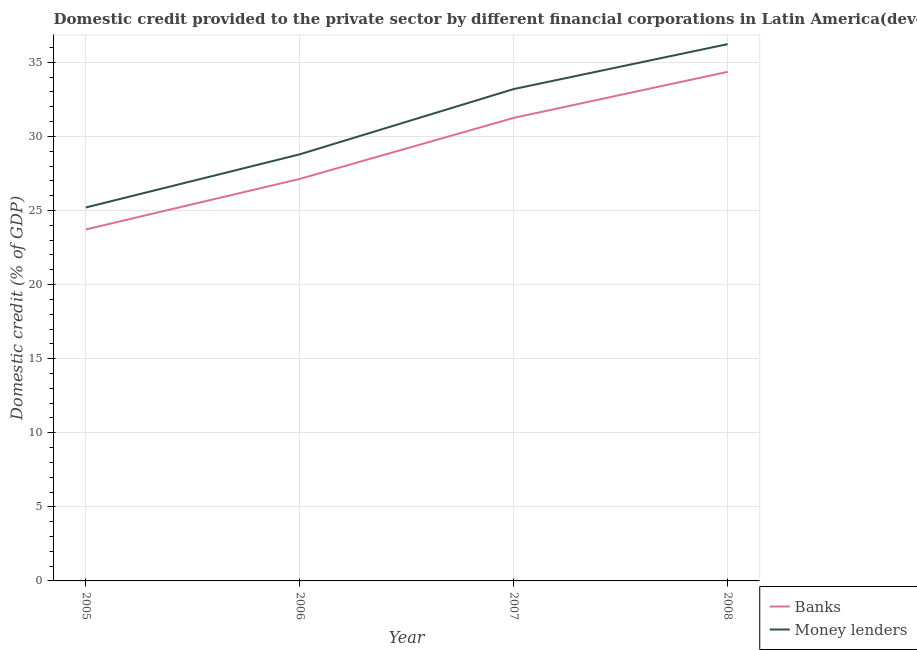Does the line corresponding to domestic credit provided by banks intersect with the line corresponding to domestic credit provided by money lenders?
Make the answer very short. No. Is the number of lines equal to the number of legend labels?
Provide a succinct answer. Yes. What is the domestic credit provided by banks in 2007?
Offer a very short reply. 31.25. Across all years, what is the maximum domestic credit provided by banks?
Make the answer very short. 34.35. Across all years, what is the minimum domestic credit provided by banks?
Provide a succinct answer. 23.72. What is the total domestic credit provided by banks in the graph?
Your answer should be compact. 116.45. What is the difference between the domestic credit provided by money lenders in 2005 and that in 2007?
Your answer should be compact. -7.99. What is the difference between the domestic credit provided by money lenders in 2005 and the domestic credit provided by banks in 2006?
Give a very brief answer. -1.93. What is the average domestic credit provided by money lenders per year?
Your answer should be very brief. 30.85. In the year 2006, what is the difference between the domestic credit provided by money lenders and domestic credit provided by banks?
Provide a short and direct response. 1.66. In how many years, is the domestic credit provided by banks greater than 11 %?
Offer a very short reply. 4. What is the ratio of the domestic credit provided by banks in 2007 to that in 2008?
Ensure brevity in your answer.  0.91. What is the difference between the highest and the second highest domestic credit provided by money lenders?
Provide a succinct answer. 3.03. What is the difference between the highest and the lowest domestic credit provided by money lenders?
Give a very brief answer. 11.02. Does the domestic credit provided by money lenders monotonically increase over the years?
Give a very brief answer. Yes. How many lines are there?
Your answer should be compact. 2. How many years are there in the graph?
Keep it short and to the point. 4. What is the difference between two consecutive major ticks on the Y-axis?
Your response must be concise. 5. Does the graph contain any zero values?
Offer a terse response. No. Does the graph contain grids?
Ensure brevity in your answer.  Yes. Where does the legend appear in the graph?
Provide a succinct answer. Bottom right. How many legend labels are there?
Provide a succinct answer. 2. What is the title of the graph?
Provide a succinct answer. Domestic credit provided to the private sector by different financial corporations in Latin America(developing only). What is the label or title of the X-axis?
Keep it short and to the point. Year. What is the label or title of the Y-axis?
Offer a very short reply. Domestic credit (% of GDP). What is the Domestic credit (% of GDP) of Banks in 2005?
Provide a succinct answer. 23.72. What is the Domestic credit (% of GDP) of Money lenders in 2005?
Your response must be concise. 25.2. What is the Domestic credit (% of GDP) in Banks in 2006?
Your answer should be compact. 27.13. What is the Domestic credit (% of GDP) of Money lenders in 2006?
Give a very brief answer. 28.79. What is the Domestic credit (% of GDP) in Banks in 2007?
Your answer should be compact. 31.25. What is the Domestic credit (% of GDP) in Money lenders in 2007?
Your response must be concise. 33.19. What is the Domestic credit (% of GDP) in Banks in 2008?
Your response must be concise. 34.35. What is the Domestic credit (% of GDP) in Money lenders in 2008?
Offer a very short reply. 36.22. Across all years, what is the maximum Domestic credit (% of GDP) in Banks?
Offer a very short reply. 34.35. Across all years, what is the maximum Domestic credit (% of GDP) of Money lenders?
Offer a terse response. 36.22. Across all years, what is the minimum Domestic credit (% of GDP) of Banks?
Offer a very short reply. 23.72. Across all years, what is the minimum Domestic credit (% of GDP) of Money lenders?
Provide a succinct answer. 25.2. What is the total Domestic credit (% of GDP) of Banks in the graph?
Offer a terse response. 116.45. What is the total Domestic credit (% of GDP) of Money lenders in the graph?
Your answer should be very brief. 123.4. What is the difference between the Domestic credit (% of GDP) in Banks in 2005 and that in 2006?
Provide a short and direct response. -3.41. What is the difference between the Domestic credit (% of GDP) in Money lenders in 2005 and that in 2006?
Offer a very short reply. -3.59. What is the difference between the Domestic credit (% of GDP) of Banks in 2005 and that in 2007?
Your answer should be very brief. -7.53. What is the difference between the Domestic credit (% of GDP) in Money lenders in 2005 and that in 2007?
Ensure brevity in your answer.  -7.99. What is the difference between the Domestic credit (% of GDP) of Banks in 2005 and that in 2008?
Provide a short and direct response. -10.64. What is the difference between the Domestic credit (% of GDP) of Money lenders in 2005 and that in 2008?
Offer a very short reply. -11.02. What is the difference between the Domestic credit (% of GDP) in Banks in 2006 and that in 2007?
Provide a short and direct response. -4.12. What is the difference between the Domestic credit (% of GDP) in Money lenders in 2006 and that in 2007?
Your answer should be compact. -4.4. What is the difference between the Domestic credit (% of GDP) in Banks in 2006 and that in 2008?
Give a very brief answer. -7.22. What is the difference between the Domestic credit (% of GDP) of Money lenders in 2006 and that in 2008?
Make the answer very short. -7.44. What is the difference between the Domestic credit (% of GDP) in Banks in 2007 and that in 2008?
Give a very brief answer. -3.11. What is the difference between the Domestic credit (% of GDP) in Money lenders in 2007 and that in 2008?
Make the answer very short. -3.03. What is the difference between the Domestic credit (% of GDP) of Banks in 2005 and the Domestic credit (% of GDP) of Money lenders in 2006?
Ensure brevity in your answer.  -5.07. What is the difference between the Domestic credit (% of GDP) of Banks in 2005 and the Domestic credit (% of GDP) of Money lenders in 2007?
Your answer should be compact. -9.47. What is the difference between the Domestic credit (% of GDP) in Banks in 2005 and the Domestic credit (% of GDP) in Money lenders in 2008?
Your response must be concise. -12.51. What is the difference between the Domestic credit (% of GDP) in Banks in 2006 and the Domestic credit (% of GDP) in Money lenders in 2007?
Make the answer very short. -6.06. What is the difference between the Domestic credit (% of GDP) of Banks in 2006 and the Domestic credit (% of GDP) of Money lenders in 2008?
Your answer should be compact. -9.09. What is the difference between the Domestic credit (% of GDP) of Banks in 2007 and the Domestic credit (% of GDP) of Money lenders in 2008?
Give a very brief answer. -4.98. What is the average Domestic credit (% of GDP) of Banks per year?
Ensure brevity in your answer.  29.11. What is the average Domestic credit (% of GDP) of Money lenders per year?
Make the answer very short. 30.85. In the year 2005, what is the difference between the Domestic credit (% of GDP) in Banks and Domestic credit (% of GDP) in Money lenders?
Ensure brevity in your answer.  -1.48. In the year 2006, what is the difference between the Domestic credit (% of GDP) in Banks and Domestic credit (% of GDP) in Money lenders?
Your response must be concise. -1.66. In the year 2007, what is the difference between the Domestic credit (% of GDP) in Banks and Domestic credit (% of GDP) in Money lenders?
Make the answer very short. -1.94. In the year 2008, what is the difference between the Domestic credit (% of GDP) in Banks and Domestic credit (% of GDP) in Money lenders?
Provide a succinct answer. -1.87. What is the ratio of the Domestic credit (% of GDP) of Banks in 2005 to that in 2006?
Offer a terse response. 0.87. What is the ratio of the Domestic credit (% of GDP) of Money lenders in 2005 to that in 2006?
Your answer should be compact. 0.88. What is the ratio of the Domestic credit (% of GDP) of Banks in 2005 to that in 2007?
Your answer should be very brief. 0.76. What is the ratio of the Domestic credit (% of GDP) in Money lenders in 2005 to that in 2007?
Your answer should be very brief. 0.76. What is the ratio of the Domestic credit (% of GDP) of Banks in 2005 to that in 2008?
Offer a terse response. 0.69. What is the ratio of the Domestic credit (% of GDP) of Money lenders in 2005 to that in 2008?
Your response must be concise. 0.7. What is the ratio of the Domestic credit (% of GDP) in Banks in 2006 to that in 2007?
Offer a terse response. 0.87. What is the ratio of the Domestic credit (% of GDP) in Money lenders in 2006 to that in 2007?
Keep it short and to the point. 0.87. What is the ratio of the Domestic credit (% of GDP) of Banks in 2006 to that in 2008?
Keep it short and to the point. 0.79. What is the ratio of the Domestic credit (% of GDP) of Money lenders in 2006 to that in 2008?
Provide a short and direct response. 0.79. What is the ratio of the Domestic credit (% of GDP) in Banks in 2007 to that in 2008?
Provide a short and direct response. 0.91. What is the ratio of the Domestic credit (% of GDP) of Money lenders in 2007 to that in 2008?
Your response must be concise. 0.92. What is the difference between the highest and the second highest Domestic credit (% of GDP) of Banks?
Your answer should be compact. 3.11. What is the difference between the highest and the second highest Domestic credit (% of GDP) in Money lenders?
Your answer should be very brief. 3.03. What is the difference between the highest and the lowest Domestic credit (% of GDP) of Banks?
Offer a very short reply. 10.64. What is the difference between the highest and the lowest Domestic credit (% of GDP) in Money lenders?
Make the answer very short. 11.02. 